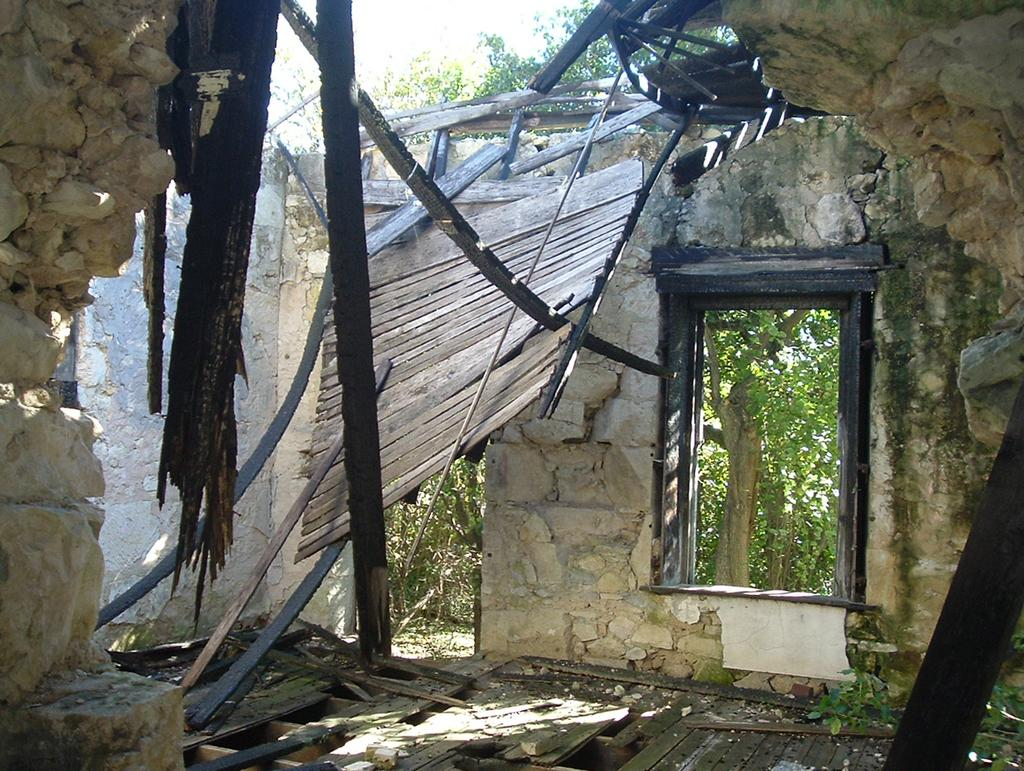What type of structure is visible in the image? There is a wall with a window in the image. What type of objects can be seen in the image? There are wooden objects in the image. What can be seen in the background of the image? There are trees visible in the image. Can you see a person interacting with a squirrel in the image? There is no person or squirrel present in the image. What channel is the image broadcasted on? The image is not a video or broadcasted content, so there is no channel associated with it. 